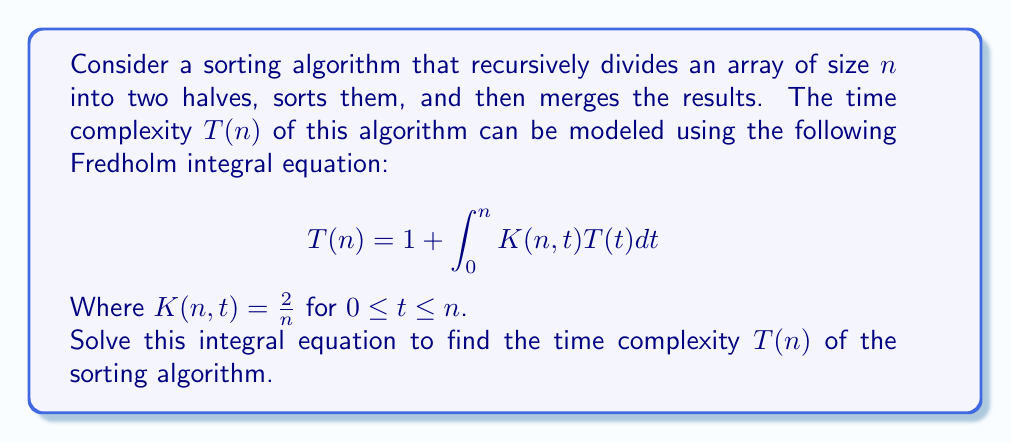Solve this math problem. Let's solve this step-by-step:

1) First, we substitute the given kernel $K(n,t) = \frac{2}{n}$ into the equation:

   $$T(n) = 1 + \int_0^n \frac{2}{n}T(t)dt$$

2) We can take $\frac{2}{n}$ out of the integral as it's constant with respect to $t$:

   $$T(n) = 1 + \frac{2}{n}\int_0^n T(t)dt$$

3) Now, let's differentiate both sides with respect to $n$:

   $$\frac{dT}{dn} = 0 + \frac{d}{dn}\left(\frac{2}{n}\int_0^n T(t)dt\right)$$

4) Using the product rule and the fundamental theorem of calculus:

   $$\frac{dT}{dn} = -\frac{2}{n^2}\int_0^n T(t)dt + \frac{2}{n}T(n)$$

5) Multiply both sides by $n$:

   $$n\frac{dT}{dn} = -\frac{2}{n}\int_0^n T(t)dt + 2T(n)$$

6) From step 2, we know that $\frac{2}{n}\int_0^n T(t)dt = T(n) - 1$. Substituting this:

   $$n\frac{dT}{dn} = -(T(n) - 1) + 2T(n) = T(n) + 1$$

7) Rearranging:

   $$n\frac{dT}{dn} - T(n) = 1$$

8) This is a linear first-order differential equation. The general solution is:

   $$T(n) = n\log n + cn$$

9) To find $c$, we use the initial condition $T(1) = 1$:

   $$1 = 1\log 1 + c(1)$$
   $$c = 1$$

Therefore, the solution is:

$$T(n) = n\log n + n$$

This is the time complexity of the sorting algorithm.
Answer: $T(n) = n\log n + n$ 